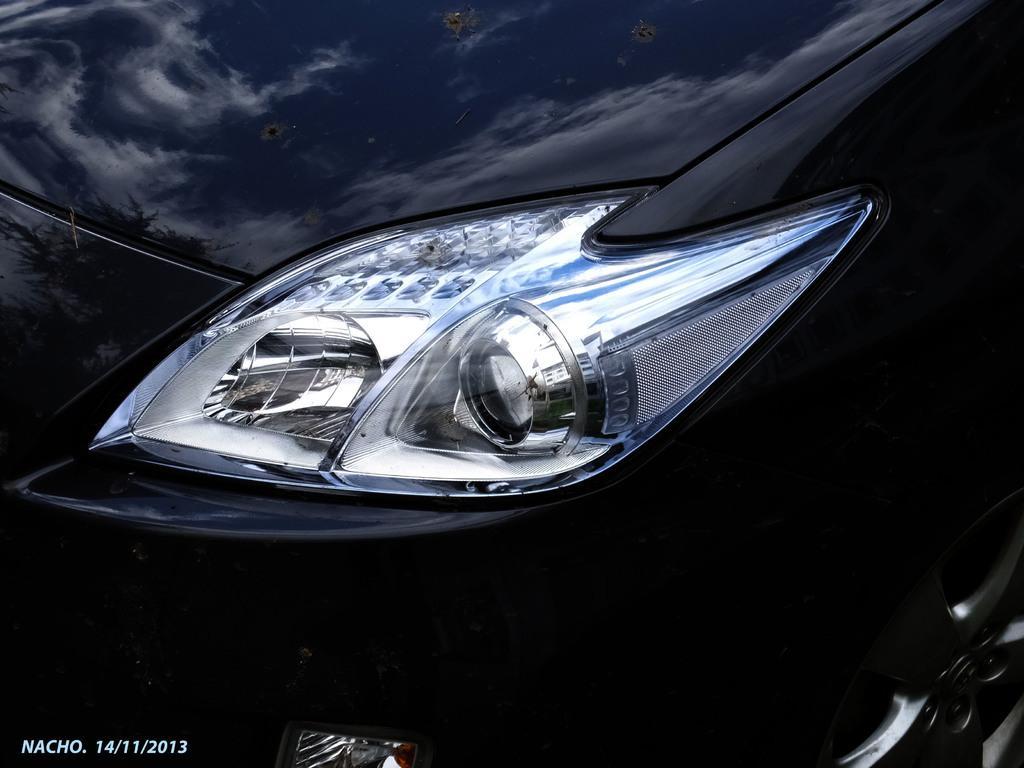Could you give a brief overview of what you see in this image? In this image there is a car with a head light. The car is black in color. 